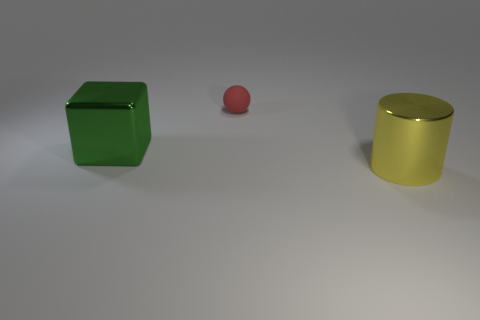What is the lighting situation in the image? The image shows a soft and diffused lighting condition. There are no harsh shadows or bright highlights, suggesting that the light source is not directly visible and is probably diffused through a softbox or similar means to create an even illumination across the scene. 